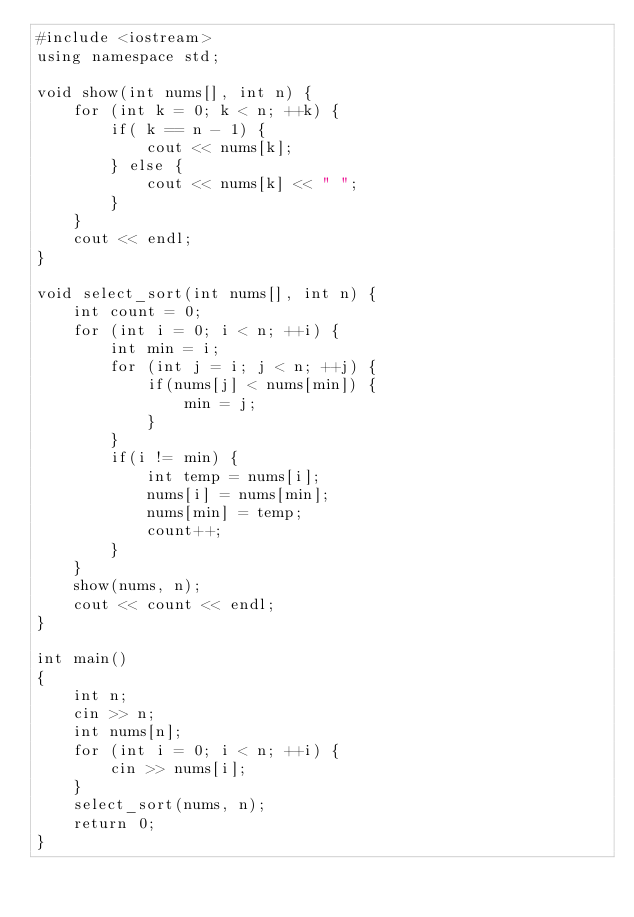<code> <loc_0><loc_0><loc_500><loc_500><_C++_>#include <iostream>
using namespace std;

void show(int nums[], int n) {
    for (int k = 0; k < n; ++k) {
        if( k == n - 1) {
            cout << nums[k];
        } else {
            cout << nums[k] << " ";
        }
    }
    cout << endl;
}

void select_sort(int nums[], int n) {
    int count = 0;
    for (int i = 0; i < n; ++i) {
        int min = i;
        for (int j = i; j < n; ++j) {
            if(nums[j] < nums[min]) {
                min = j;
            }
        }
        if(i != min) {
            int temp = nums[i];
            nums[i] = nums[min];
            nums[min] = temp;
            count++;
        }
    }
    show(nums, n);
    cout << count << endl;
}

int main()
{
    int n;
    cin >> n;
    int nums[n];
    for (int i = 0; i < n; ++i) {
        cin >> nums[i];
    }
    select_sort(nums, n);
    return 0;
}</code> 